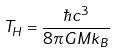Convert formula to latex. <formula><loc_0><loc_0><loc_500><loc_500>T _ { H } = \frac { \hbar { c } ^ { 3 } } { 8 \pi G M k _ { B } }</formula> 